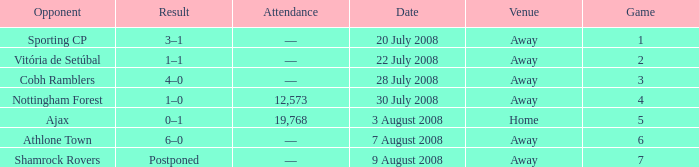Give me the full table as a dictionary. {'header': ['Opponent', 'Result', 'Attendance', 'Date', 'Venue', 'Game'], 'rows': [['Sporting CP', '3–1', '—', '20 July 2008', 'Away', '1'], ['Vitória de Setúbal', '1–1', '—', '22 July 2008', 'Away', '2'], ['Cobh Ramblers', '4–0', '—', '28 July 2008', 'Away', '3'], ['Nottingham Forest', '1–0', '12,573', '30 July 2008', 'Away', '4'], ['Ajax', '0–1', '19,768', '3 August 2008', 'Home', '5'], ['Athlone Town', '6–0', '—', '7 August 2008', 'Away', '6'], ['Shamrock Rovers', 'Postponed', '—', '9 August 2008', 'Away', '7']]} What is the lowest game number on 20 July 2008? 1.0. 